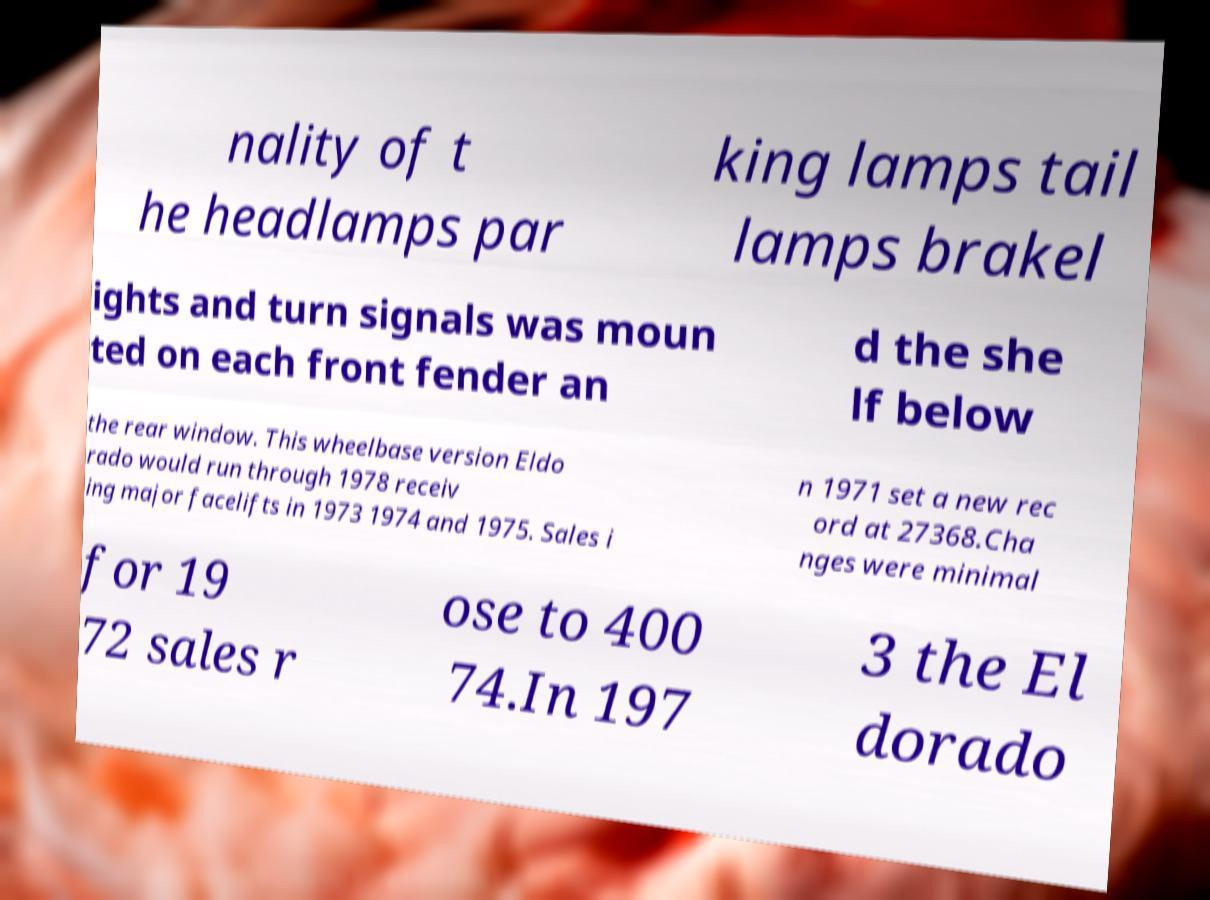What messages or text are displayed in this image? I need them in a readable, typed format. nality of t he headlamps par king lamps tail lamps brakel ights and turn signals was moun ted on each front fender an d the she lf below the rear window. This wheelbase version Eldo rado would run through 1978 receiv ing major facelifts in 1973 1974 and 1975. Sales i n 1971 set a new rec ord at 27368.Cha nges were minimal for 19 72 sales r ose to 400 74.In 197 3 the El dorado 